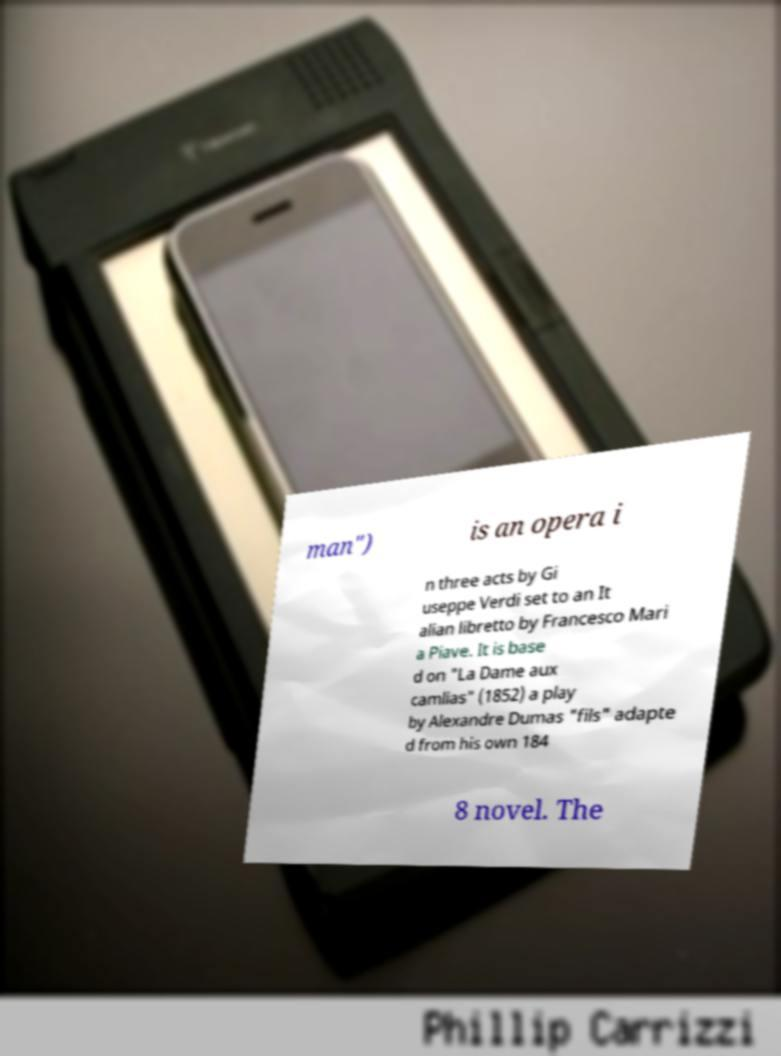Can you read and provide the text displayed in the image?This photo seems to have some interesting text. Can you extract and type it out for me? man") is an opera i n three acts by Gi useppe Verdi set to an It alian libretto by Francesco Mari a Piave. It is base d on "La Dame aux camlias" (1852) a play by Alexandre Dumas "fils" adapte d from his own 184 8 novel. The 